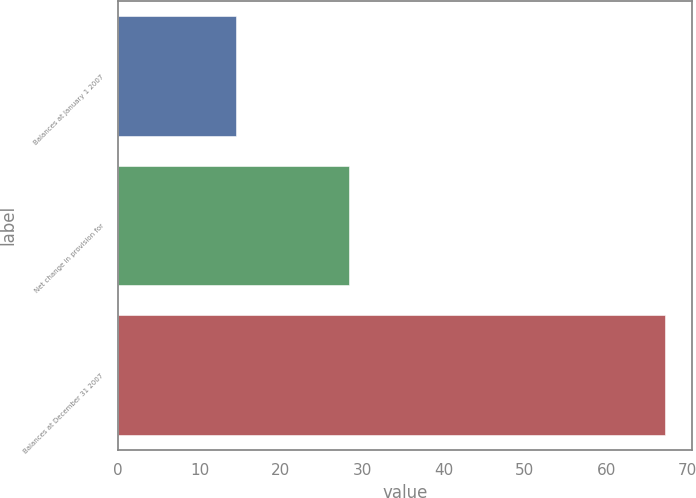Convert chart to OTSL. <chart><loc_0><loc_0><loc_500><loc_500><bar_chart><fcel>Balances at January 1 2007<fcel>Net change in provision for<fcel>Balances at December 31 2007<nl><fcel>14.5<fcel>28.4<fcel>67.2<nl></chart> 